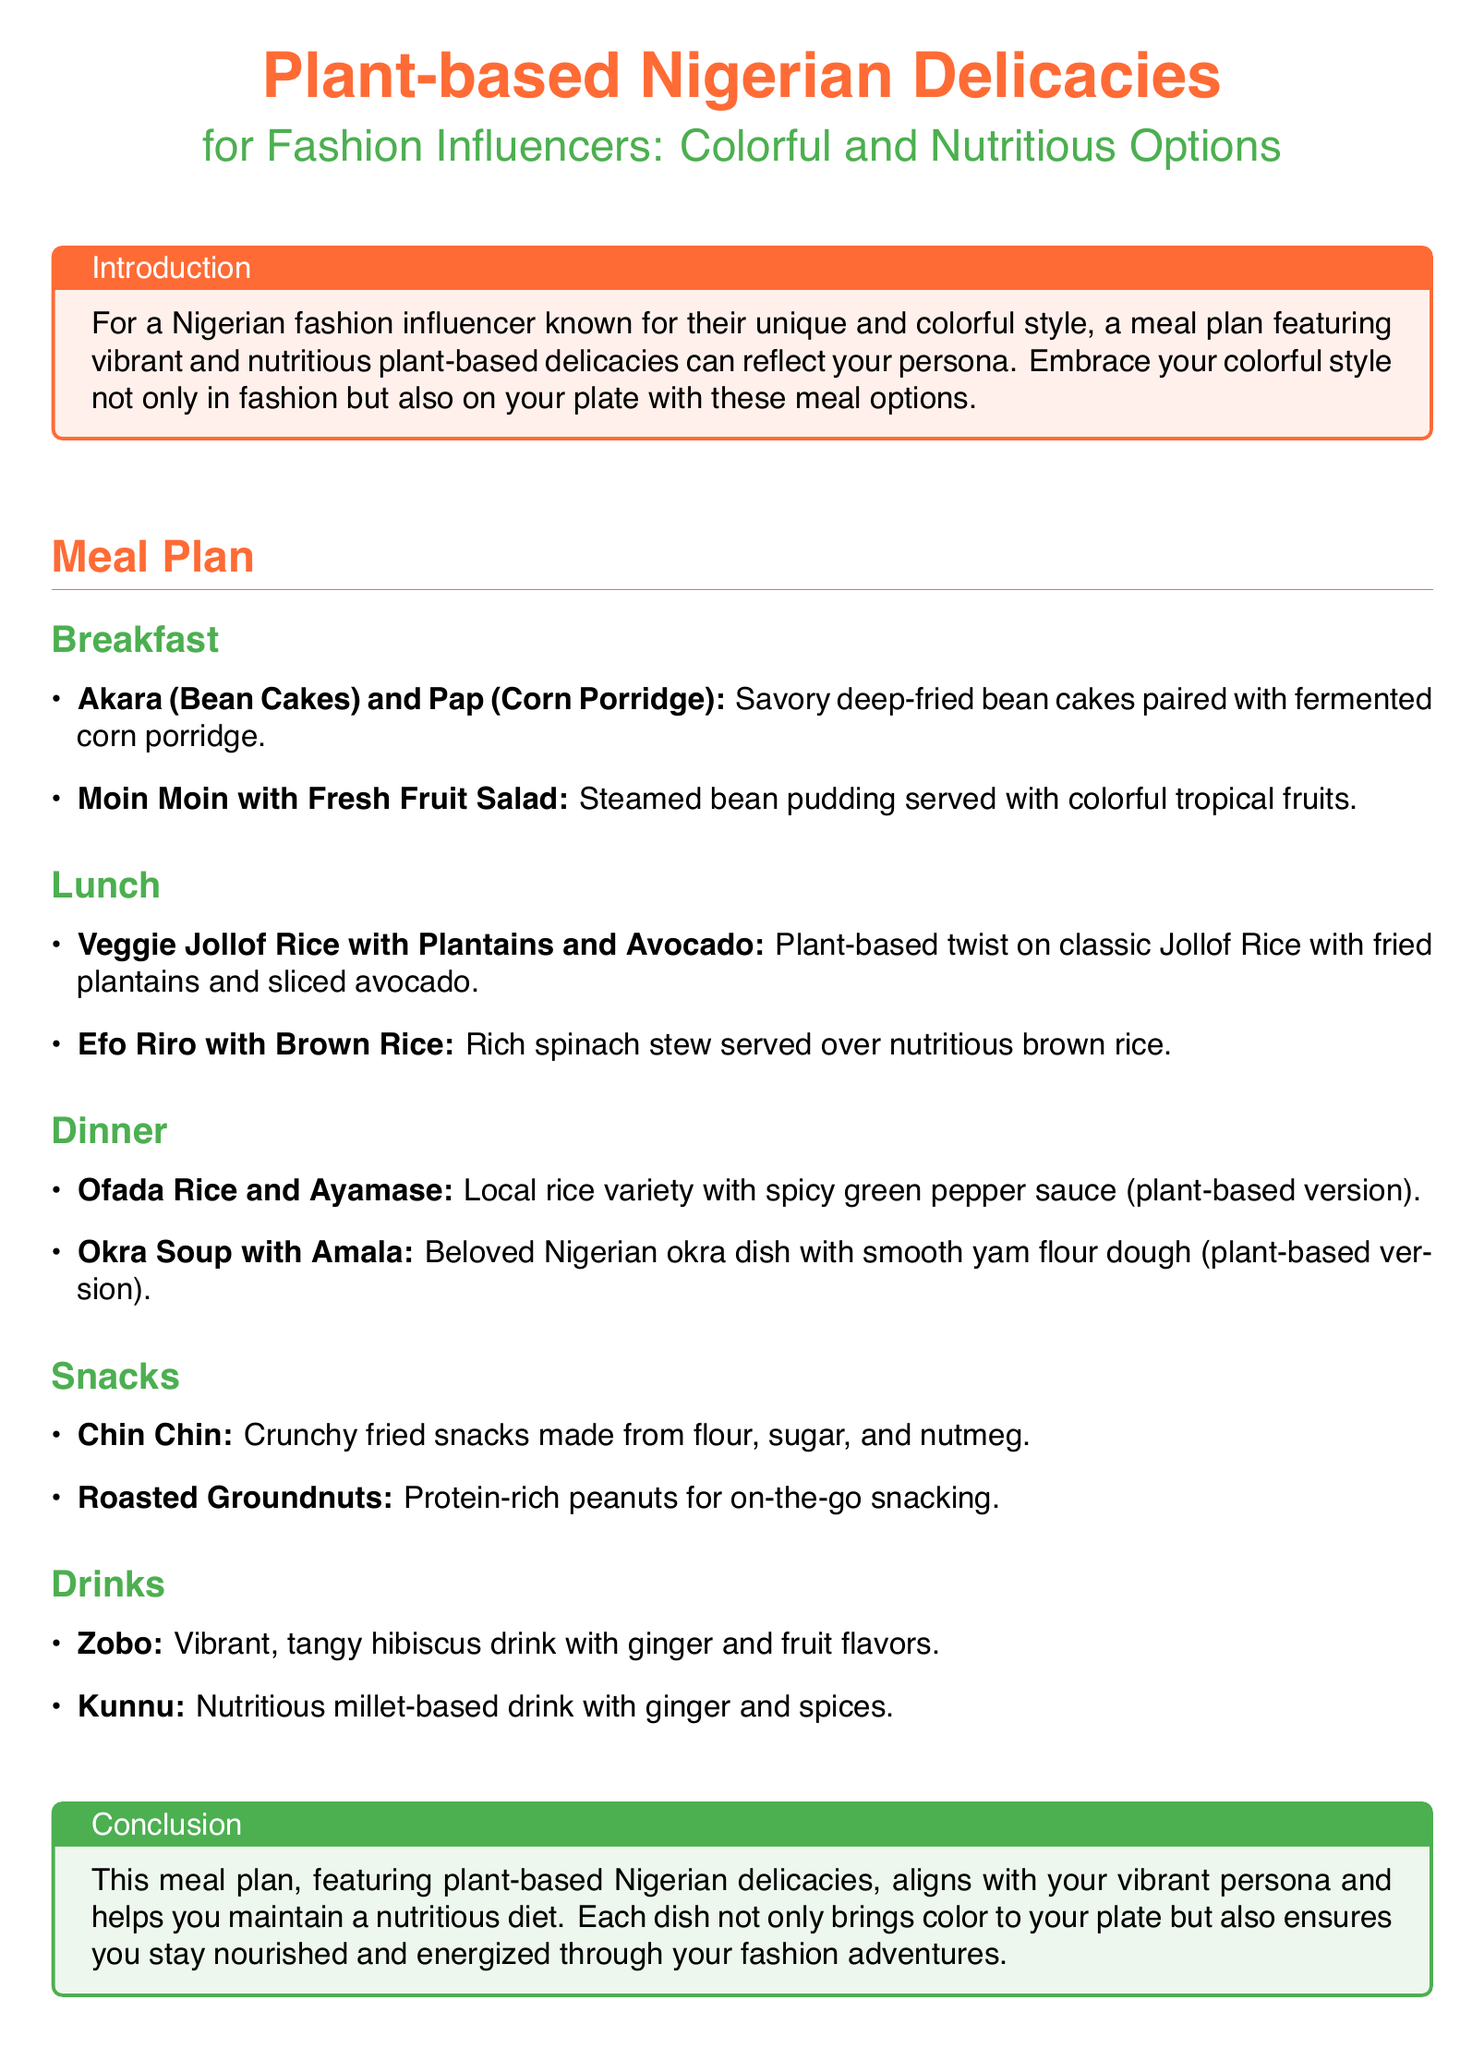What is the first breakfast option? The first breakfast option mentioned in the document is Akara and Pap.
Answer: Akara (Bean Cakes) and Pap (Corn Porridge) What is served with Moin Moin? Moin Moin is served with colorful tropical fruits.
Answer: Fresh Fruit Salad Which dish is associated with lunch? The document lists Veggie Jollof Rice with Plantains and Avocado as a lunch option.
Answer: Veggie Jollof Rice with Plantains and Avocado How many snacks are provided in the meal plan? The document lists two snacks: Chin Chin and Roasted Groundnuts, totaling to a number.
Answer: 2 What drink is made from hibiscus? The document states Zobo is the vibrant drink made from hibiscus.
Answer: Zobo What type of rice is paired with Ayamase? The document specifies Ofada Rice is paired with Ayamase.
Answer: Ofada Rice What is the color theme of the document headings? The headings of the document use a primary color theme for text.
Answer: Primary color Which food category includes protein-rich options? The snacks section includes protein-rich peanuts.
Answer: Snacks 